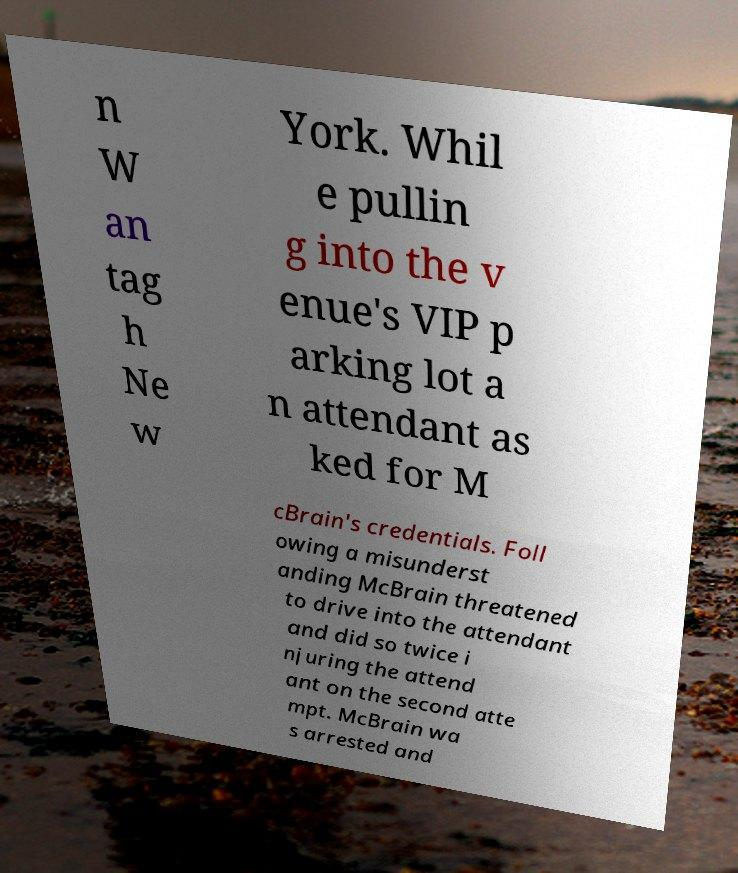Can you accurately transcribe the text from the provided image for me? n W an tag h Ne w York. Whil e pullin g into the v enue's VIP p arking lot a n attendant as ked for M cBrain's credentials. Foll owing a misunderst anding McBrain threatened to drive into the attendant and did so twice i njuring the attend ant on the second atte mpt. McBrain wa s arrested and 